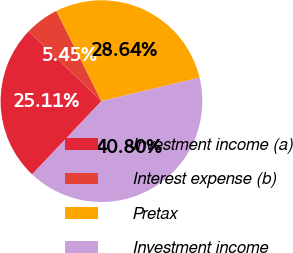Convert chart to OTSL. <chart><loc_0><loc_0><loc_500><loc_500><pie_chart><fcel>Investment income (a)<fcel>Interest expense (b)<fcel>Pretax<fcel>Investment income<nl><fcel>25.11%<fcel>5.45%<fcel>28.64%<fcel>40.8%<nl></chart> 